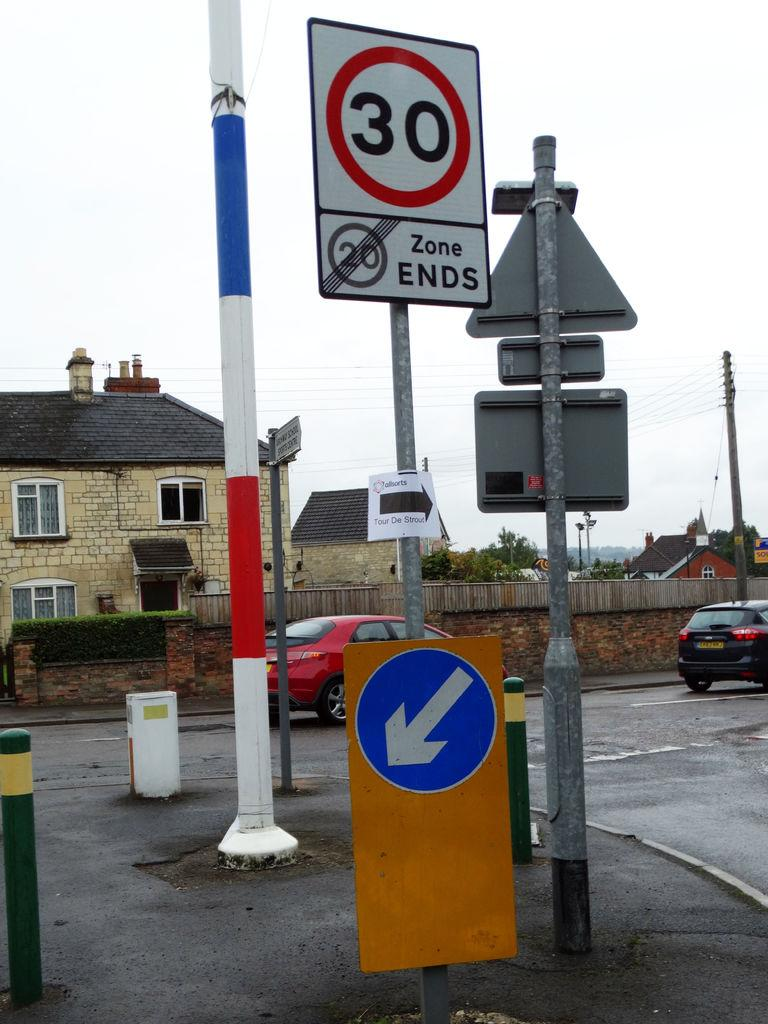<image>
Create a compact narrative representing the image presented. A white, black and red sign that says 30 in the center is sitting at an intersection. 